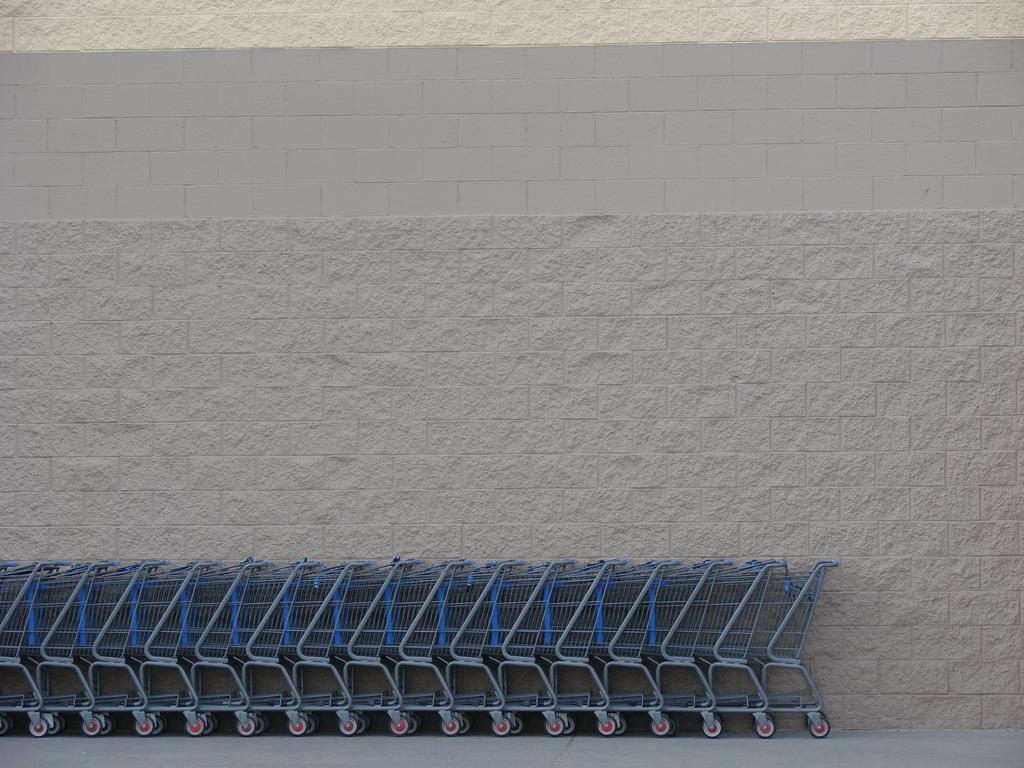What type of objects can be seen in the image? There are shopping mall trolleys in the image. What else can be seen in the image besides the trolleys? There is a wall visible in the image. How many quinces are hanging from the wall in the image? There are no quinces present in the image; only shopping mall trolleys and a wall are visible. 